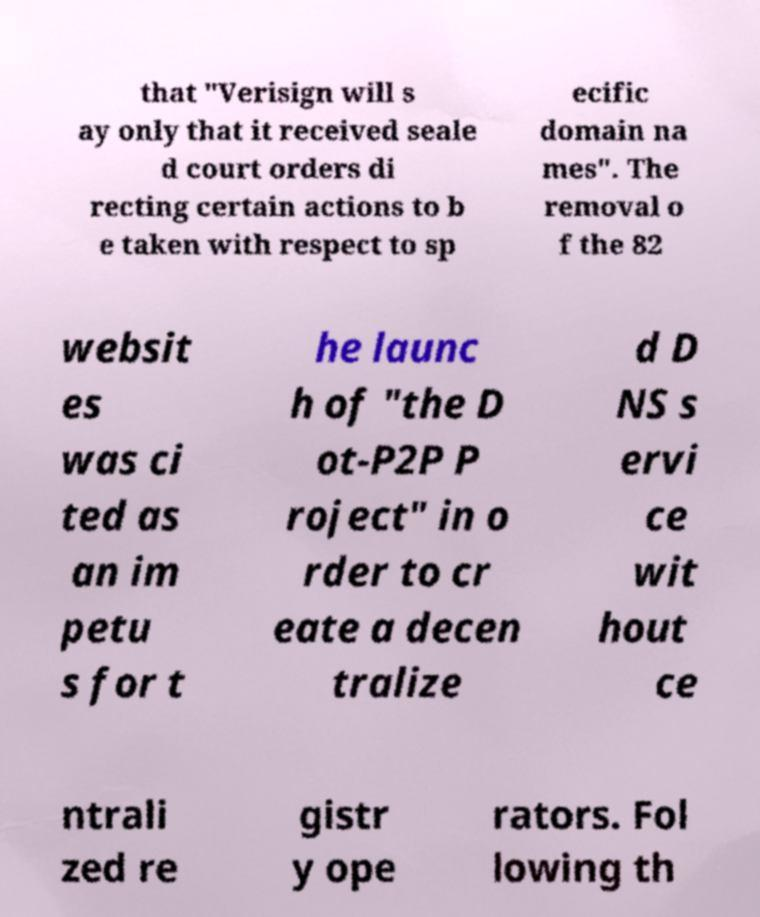For documentation purposes, I need the text within this image transcribed. Could you provide that? that "Verisign will s ay only that it received seale d court orders di recting certain actions to b e taken with respect to sp ecific domain na mes". The removal o f the 82 websit es was ci ted as an im petu s for t he launc h of "the D ot-P2P P roject" in o rder to cr eate a decen tralize d D NS s ervi ce wit hout ce ntrali zed re gistr y ope rators. Fol lowing th 